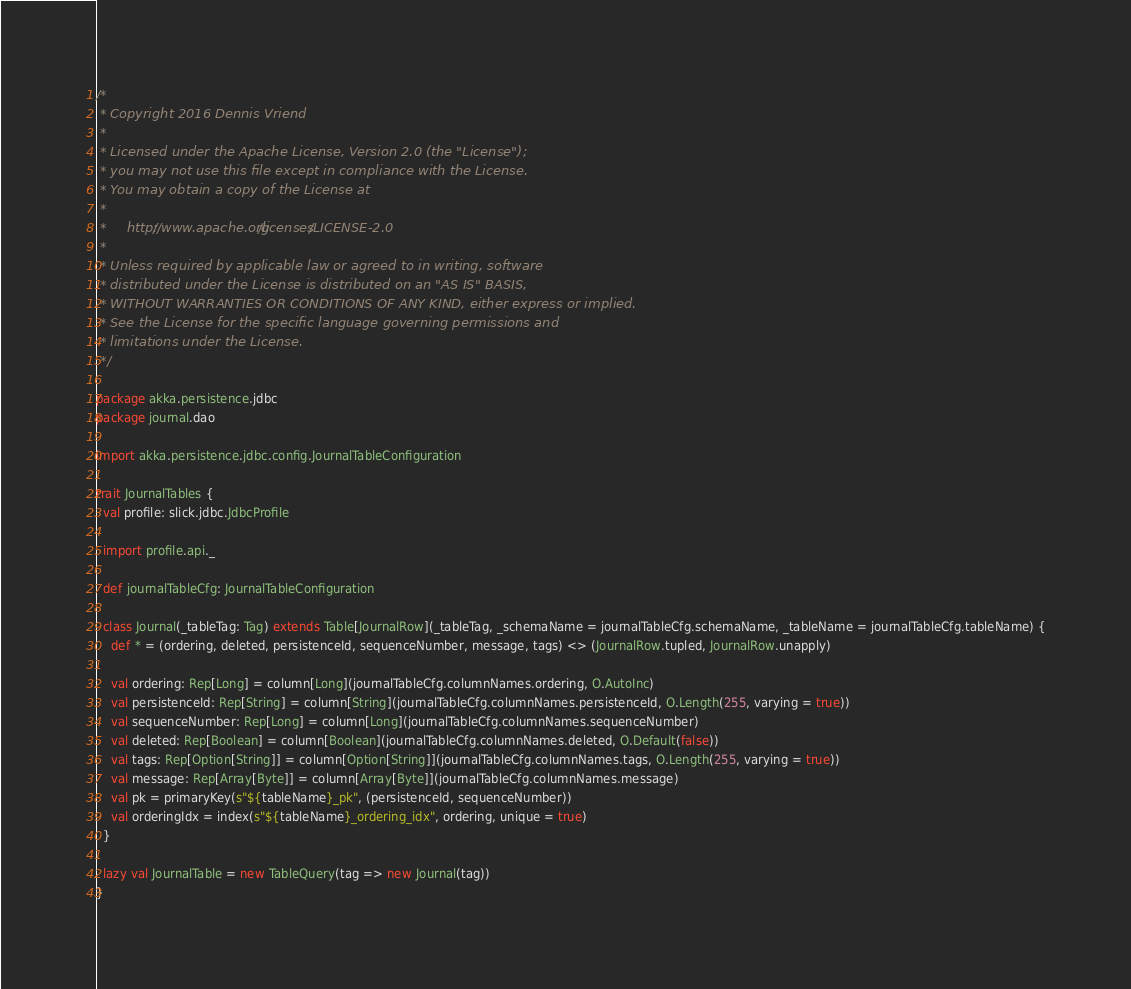<code> <loc_0><loc_0><loc_500><loc_500><_Scala_>/*
 * Copyright 2016 Dennis Vriend
 *
 * Licensed under the Apache License, Version 2.0 (the "License");
 * you may not use this file except in compliance with the License.
 * You may obtain a copy of the License at
 *
 *     http://www.apache.org/licenses/LICENSE-2.0
 *
 * Unless required by applicable law or agreed to in writing, software
 * distributed under the License is distributed on an "AS IS" BASIS,
 * WITHOUT WARRANTIES OR CONDITIONS OF ANY KIND, either express or implied.
 * See the License for the specific language governing permissions and
 * limitations under the License.
 */

package akka.persistence.jdbc
package journal.dao

import akka.persistence.jdbc.config.JournalTableConfiguration

trait JournalTables {
  val profile: slick.jdbc.JdbcProfile

  import profile.api._

  def journalTableCfg: JournalTableConfiguration

  class Journal(_tableTag: Tag) extends Table[JournalRow](_tableTag, _schemaName = journalTableCfg.schemaName, _tableName = journalTableCfg.tableName) {
    def * = (ordering, deleted, persistenceId, sequenceNumber, message, tags) <> (JournalRow.tupled, JournalRow.unapply)

    val ordering: Rep[Long] = column[Long](journalTableCfg.columnNames.ordering, O.AutoInc)
    val persistenceId: Rep[String] = column[String](journalTableCfg.columnNames.persistenceId, O.Length(255, varying = true))
    val sequenceNumber: Rep[Long] = column[Long](journalTableCfg.columnNames.sequenceNumber)
    val deleted: Rep[Boolean] = column[Boolean](journalTableCfg.columnNames.deleted, O.Default(false))
    val tags: Rep[Option[String]] = column[Option[String]](journalTableCfg.columnNames.tags, O.Length(255, varying = true))
    val message: Rep[Array[Byte]] = column[Array[Byte]](journalTableCfg.columnNames.message)
    val pk = primaryKey(s"${tableName}_pk", (persistenceId, sequenceNumber))
    val orderingIdx = index(s"${tableName}_ordering_idx", ordering, unique = true)
  }

  lazy val JournalTable = new TableQuery(tag => new Journal(tag))
}
</code> 